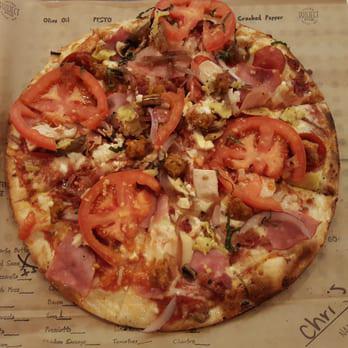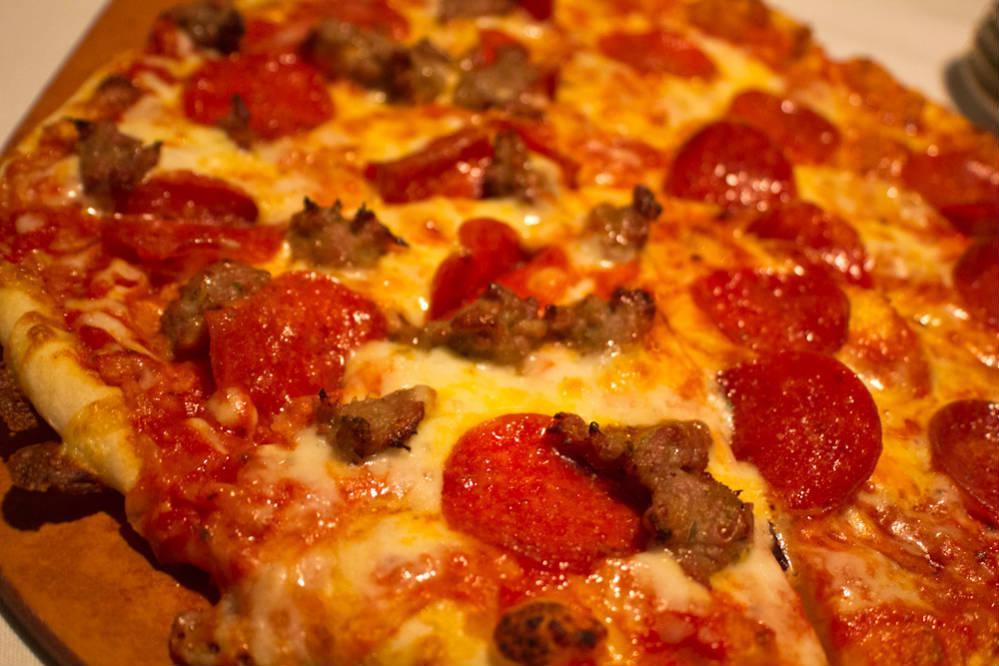The first image is the image on the left, the second image is the image on the right. Analyze the images presented: Is the assertion "Each image features a round pizza shape, and at least one image shows a pizza in a round metal dish." valid? Answer yes or no. No. The first image is the image on the left, the second image is the image on the right. Assess this claim about the two images: "Both of the pizzas contain green parts.". Correct or not? Answer yes or no. No. 